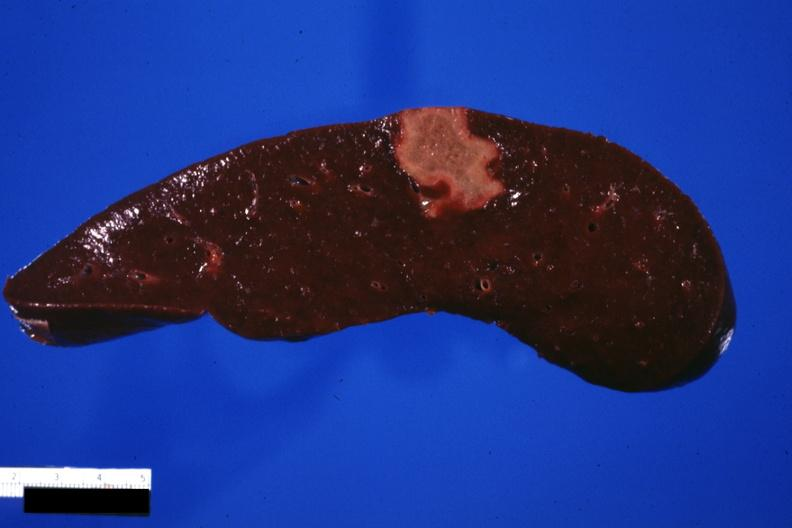where is this part in?
Answer the question using a single word or phrase. Spleen 